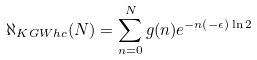Convert formula to latex. <formula><loc_0><loc_0><loc_500><loc_500>\aleph _ { K G W h c } ( N ) = \sum _ { n = 0 } ^ { N } g ( n ) e ^ { - n ( - \epsilon ) \ln 2 }</formula> 